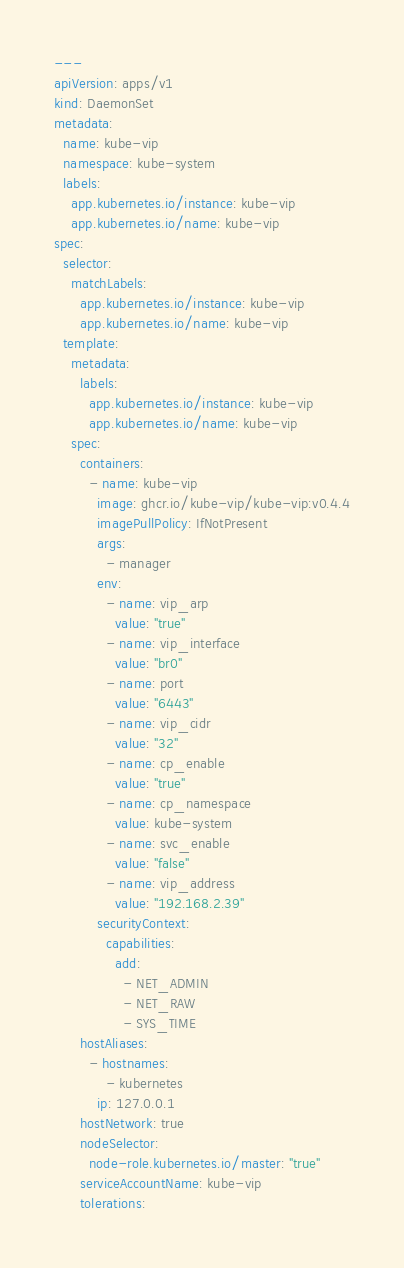<code> <loc_0><loc_0><loc_500><loc_500><_YAML_>---
apiVersion: apps/v1
kind: DaemonSet
metadata:
  name: kube-vip
  namespace: kube-system
  labels:
    app.kubernetes.io/instance: kube-vip
    app.kubernetes.io/name: kube-vip
spec:
  selector:
    matchLabels:
      app.kubernetes.io/instance: kube-vip
      app.kubernetes.io/name: kube-vip
  template:
    metadata:
      labels:
        app.kubernetes.io/instance: kube-vip
        app.kubernetes.io/name: kube-vip
    spec:
      containers:
        - name: kube-vip
          image: ghcr.io/kube-vip/kube-vip:v0.4.4
          imagePullPolicy: IfNotPresent
          args:
            - manager
          env:
            - name: vip_arp
              value: "true"
            - name: vip_interface
              value: "br0"
            - name: port
              value: "6443"
            - name: vip_cidr
              value: "32"
            - name: cp_enable
              value: "true"
            - name: cp_namespace
              value: kube-system
            - name: svc_enable
              value: "false"
            - name: vip_address
              value: "192.168.2.39"
          securityContext:
            capabilities:
              add:
                - NET_ADMIN
                - NET_RAW
                - SYS_TIME
      hostAliases:
        - hostnames:
            - kubernetes
          ip: 127.0.0.1
      hostNetwork: true
      nodeSelector:
        node-role.kubernetes.io/master: "true"
      serviceAccountName: kube-vip
      tolerations:</code> 